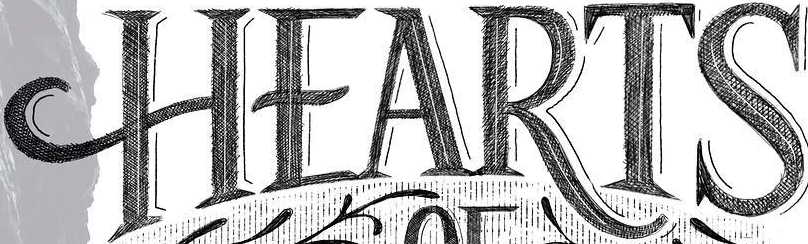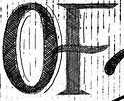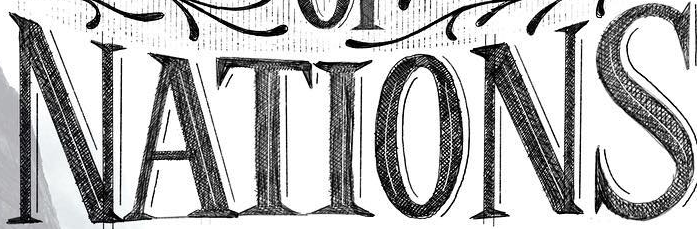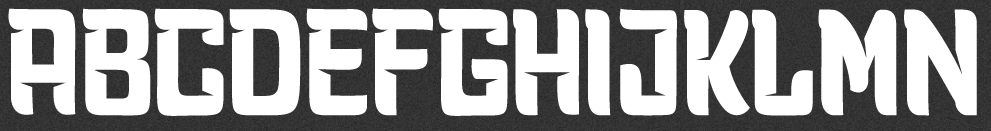What words can you see in these images in sequence, separated by a semicolon? HEARTS; OF; NATIONS; ABCDEFGHIJKLMN 